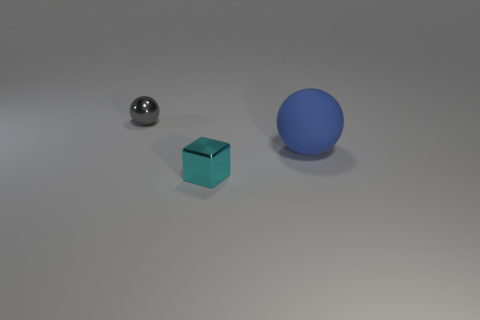Add 3 large spheres. How many objects exist? 6 Add 2 big blue balls. How many big blue balls exist? 3 Subtract 0 brown balls. How many objects are left? 3 Subtract all cubes. How many objects are left? 2 Subtract all yellow rubber things. Subtract all large balls. How many objects are left? 2 Add 1 big rubber balls. How many big rubber balls are left? 2 